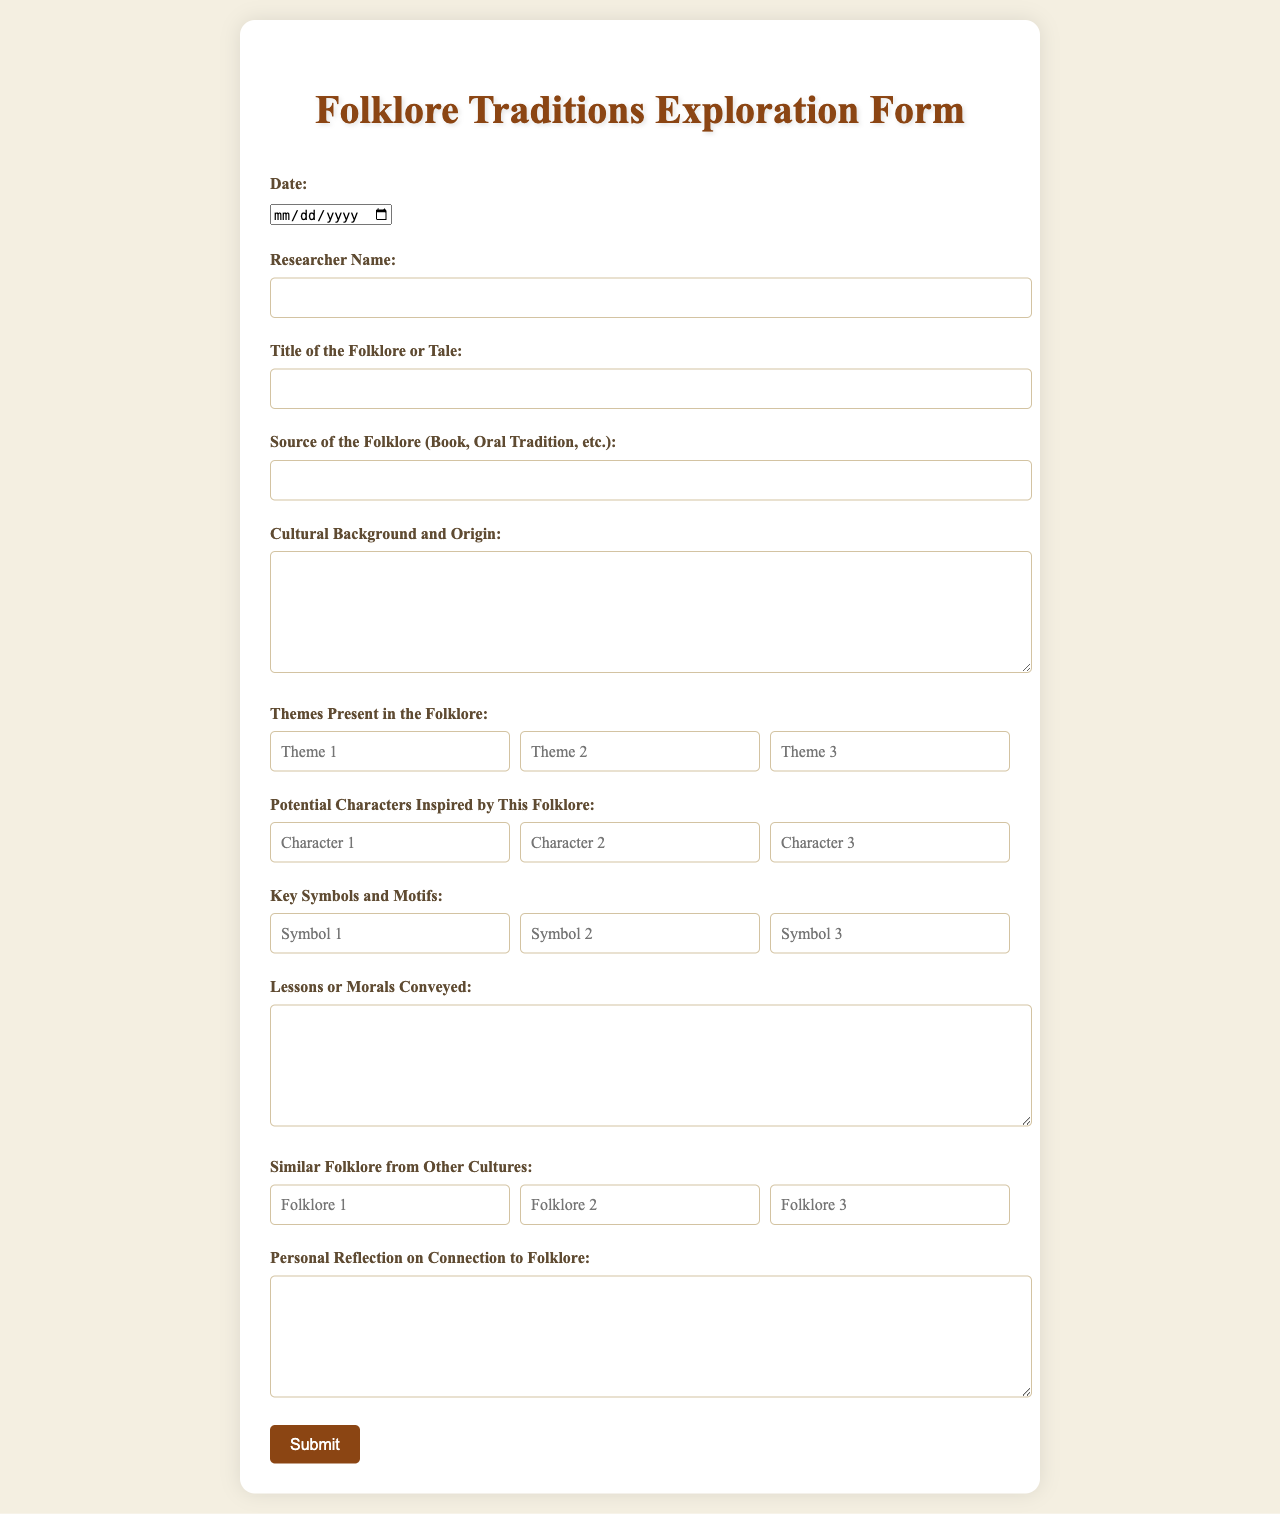what is the title of the form? The title of the form is specified in the heading section of the rendered document.
Answer: Folklore Traditions Exploration Form what is the date field asking for? The date field is meant for the researcher to provide the date related to the folklore research.
Answer: Date who is the target audience for this form? The target audience is indicated by the sections that require inputs from a researcher documenting folklore.
Answer: Researchers how many themes are there for entering folklore? The form provides three input fields for listing themes present in the folklore.
Answer: Three what should be included in the 'Source of the Folklore' section? This section is where the researcher must specify the origin of the folklore, such as a book or oral tradition.
Answer: Source Information what type of information is collected under 'Potential Characters Inspired by This Folklore'? This section collects names or ideas concerning characters that could be developed from the folklore tale.
Answer: Character Development what is the required format for inputting themes in the form? The themes are collected in multiple input fields that allow short text responses.
Answer: Short text responses what does the 'personal reflection' section ask for? This section requests the researcher's thoughts and connections to the folklore being documented.
Answer: Personal Reflection what motif-related information is the form designed to capture? The form is designed to capture key symbols and motifs related to the folklore being explored.
Answer: Key Symbols and Motifs 